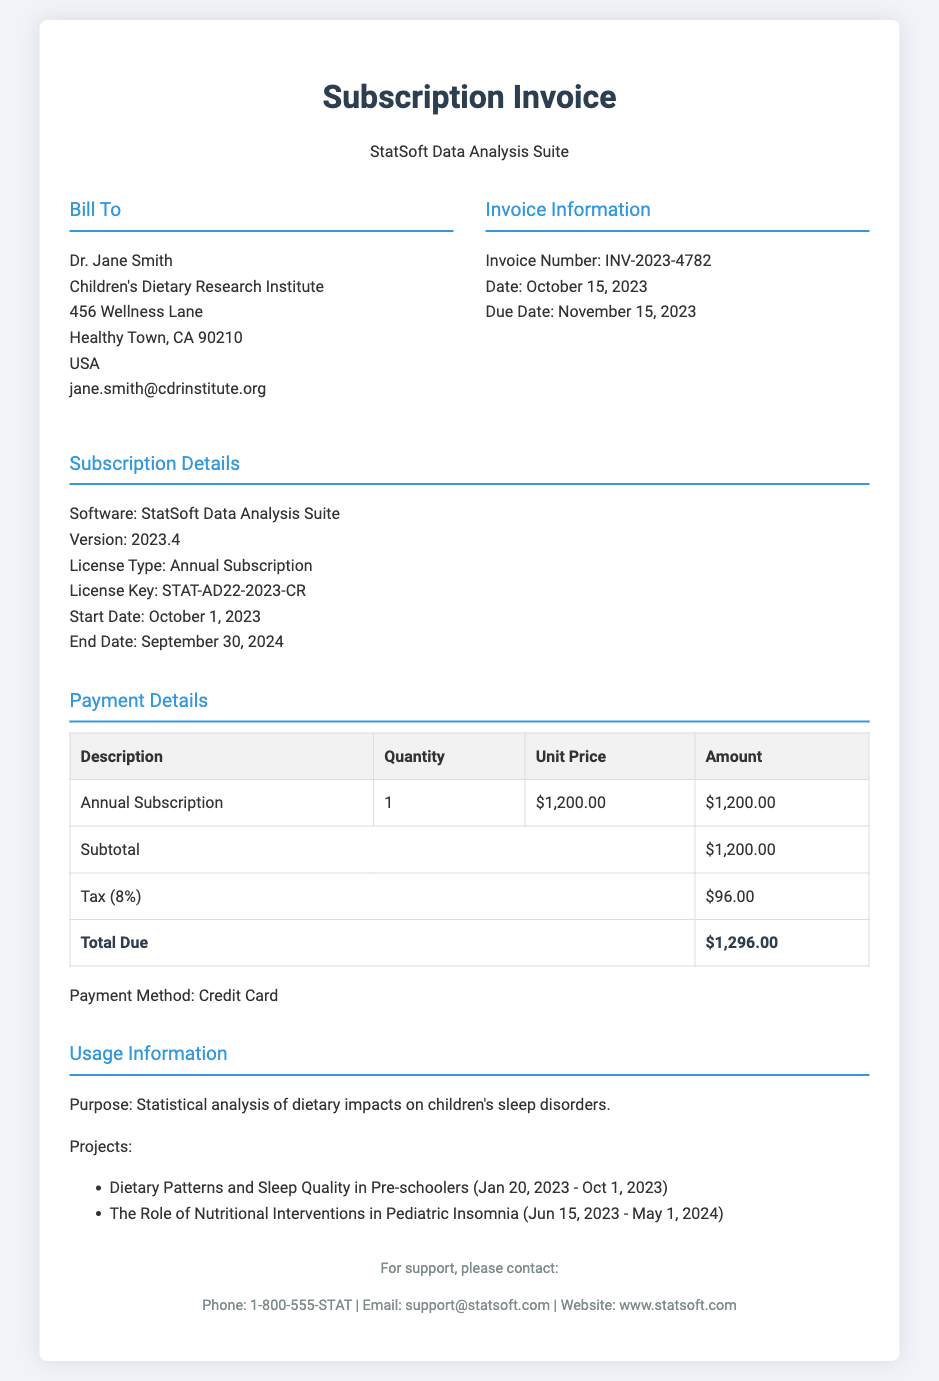What is the invoice number? The invoice number is explicitly mentioned in the document as part of the invoice information section.
Answer: INV-2023-4782 Who is the bill to? The name and affiliation of the person being billed are provided in the bill to section of the document.
Answer: Dr. Jane Smith What is the total due amount? The total due amount is calculated at the bottom of the payment details section.
Answer: $1,296.00 What is the duration of the license? The start and end dates of the subscription license indicate its duration.
Answer: October 1, 2023 - September 30, 2024 What is the purpose of the software? The purpose is stated clearly under the usage information section.
Answer: Statistical analysis of dietary impacts on children's sleep disorders How much tax is applied? The tax percentage and resulting amount are noted in the payment details table.
Answer: $96.00 What payment method was used? The payment method is specified in the payment details section of the document.
Answer: Credit Card How many projects are listed? The number of projects can be determined by counting the listed items in the usage information section.
Answer: 2 